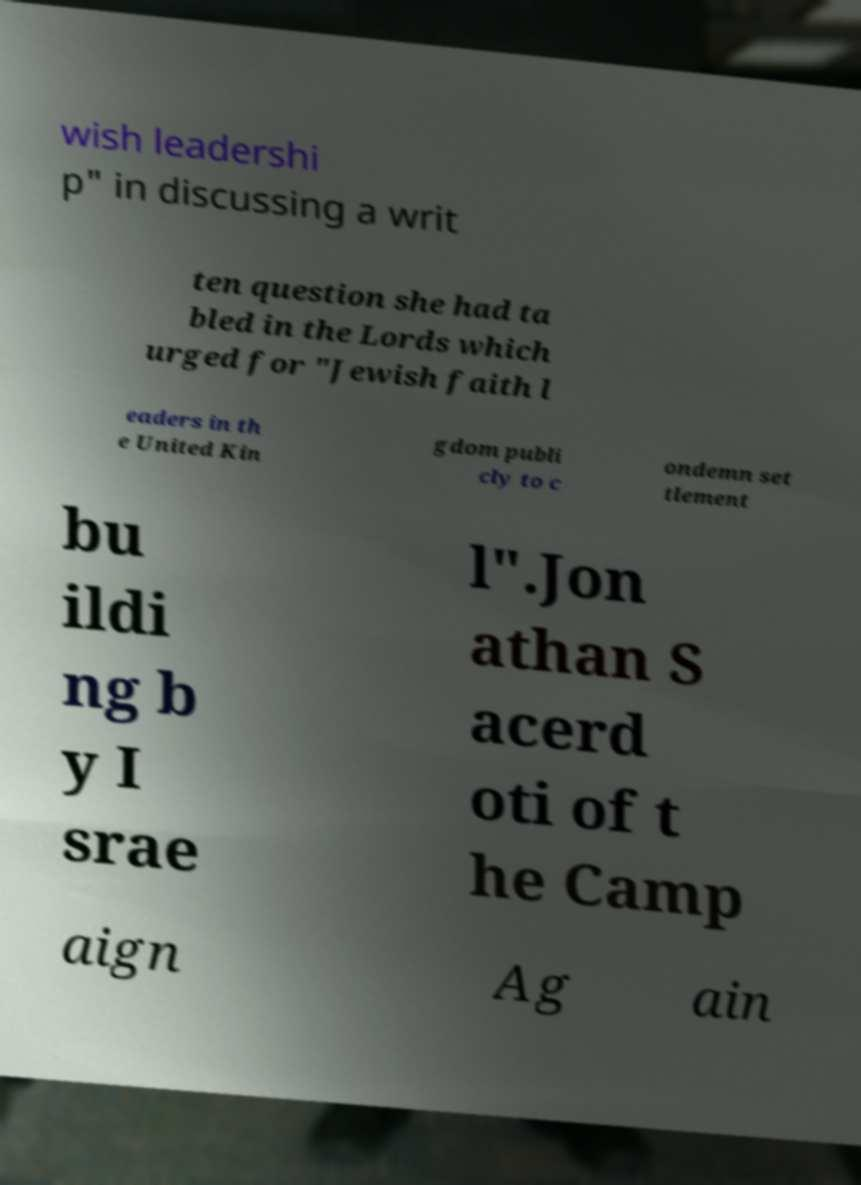For documentation purposes, I need the text within this image transcribed. Could you provide that? wish leadershi p" in discussing a writ ten question she had ta bled in the Lords which urged for "Jewish faith l eaders in th e United Kin gdom publi cly to c ondemn set tlement bu ildi ng b y I srae l".Jon athan S acerd oti of t he Camp aign Ag ain 